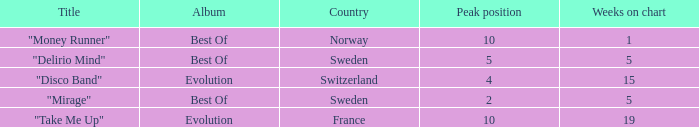What is the weeks on chart for the single from france? 19.0. 